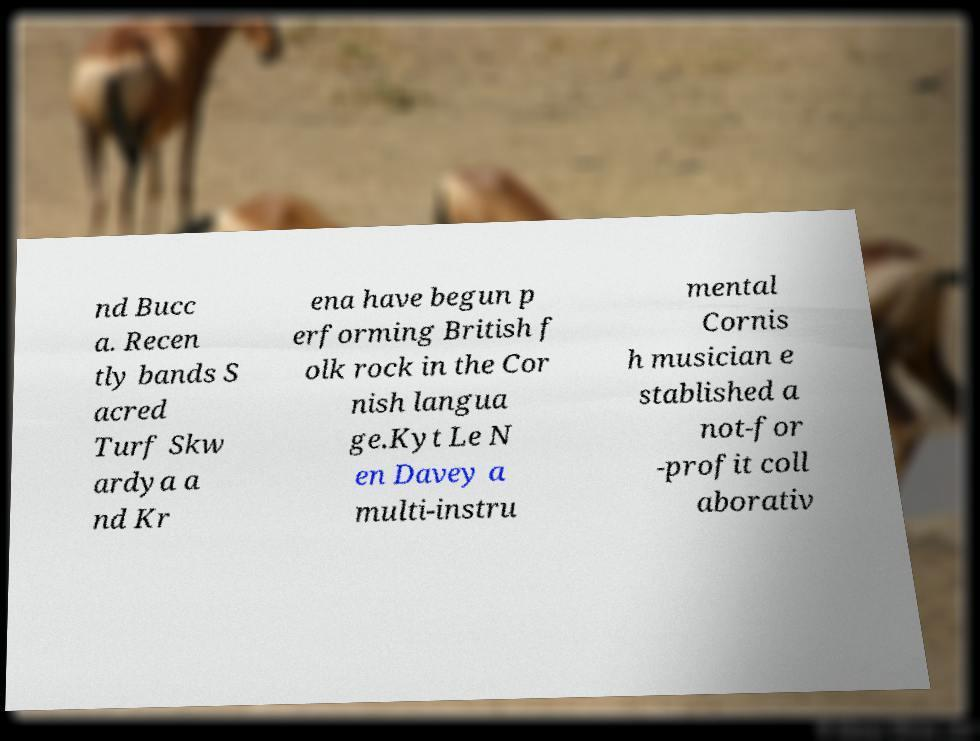Could you extract and type out the text from this image? nd Bucc a. Recen tly bands S acred Turf Skw ardya a nd Kr ena have begun p erforming British f olk rock in the Cor nish langua ge.Kyt Le N en Davey a multi-instru mental Cornis h musician e stablished a not-for -profit coll aborativ 